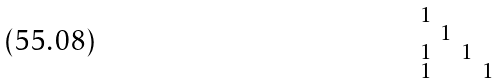Convert formula to latex. <formula><loc_0><loc_0><loc_500><loc_500>\begin{smallmatrix} 1 & & & \\ & 1 & & \\ 1 & & 1 & \\ 1 & & & 1 \end{smallmatrix}</formula> 